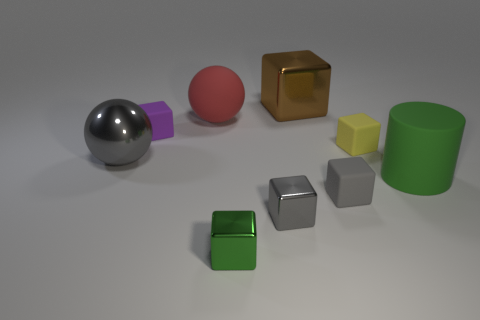Subtract all tiny green shiny cubes. How many cubes are left? 5 Subtract all green balls. How many gray blocks are left? 2 Subtract 3 cubes. How many cubes are left? 3 Subtract all yellow blocks. How many blocks are left? 5 Add 1 tiny brown spheres. How many objects exist? 10 Subtract all blue cubes. Subtract all green cylinders. How many cubes are left? 6 Subtract all cylinders. How many objects are left? 8 Subtract 0 cyan cylinders. How many objects are left? 9 Subtract all small gray rubber balls. Subtract all blocks. How many objects are left? 3 Add 5 tiny matte cubes. How many tiny matte cubes are left? 8 